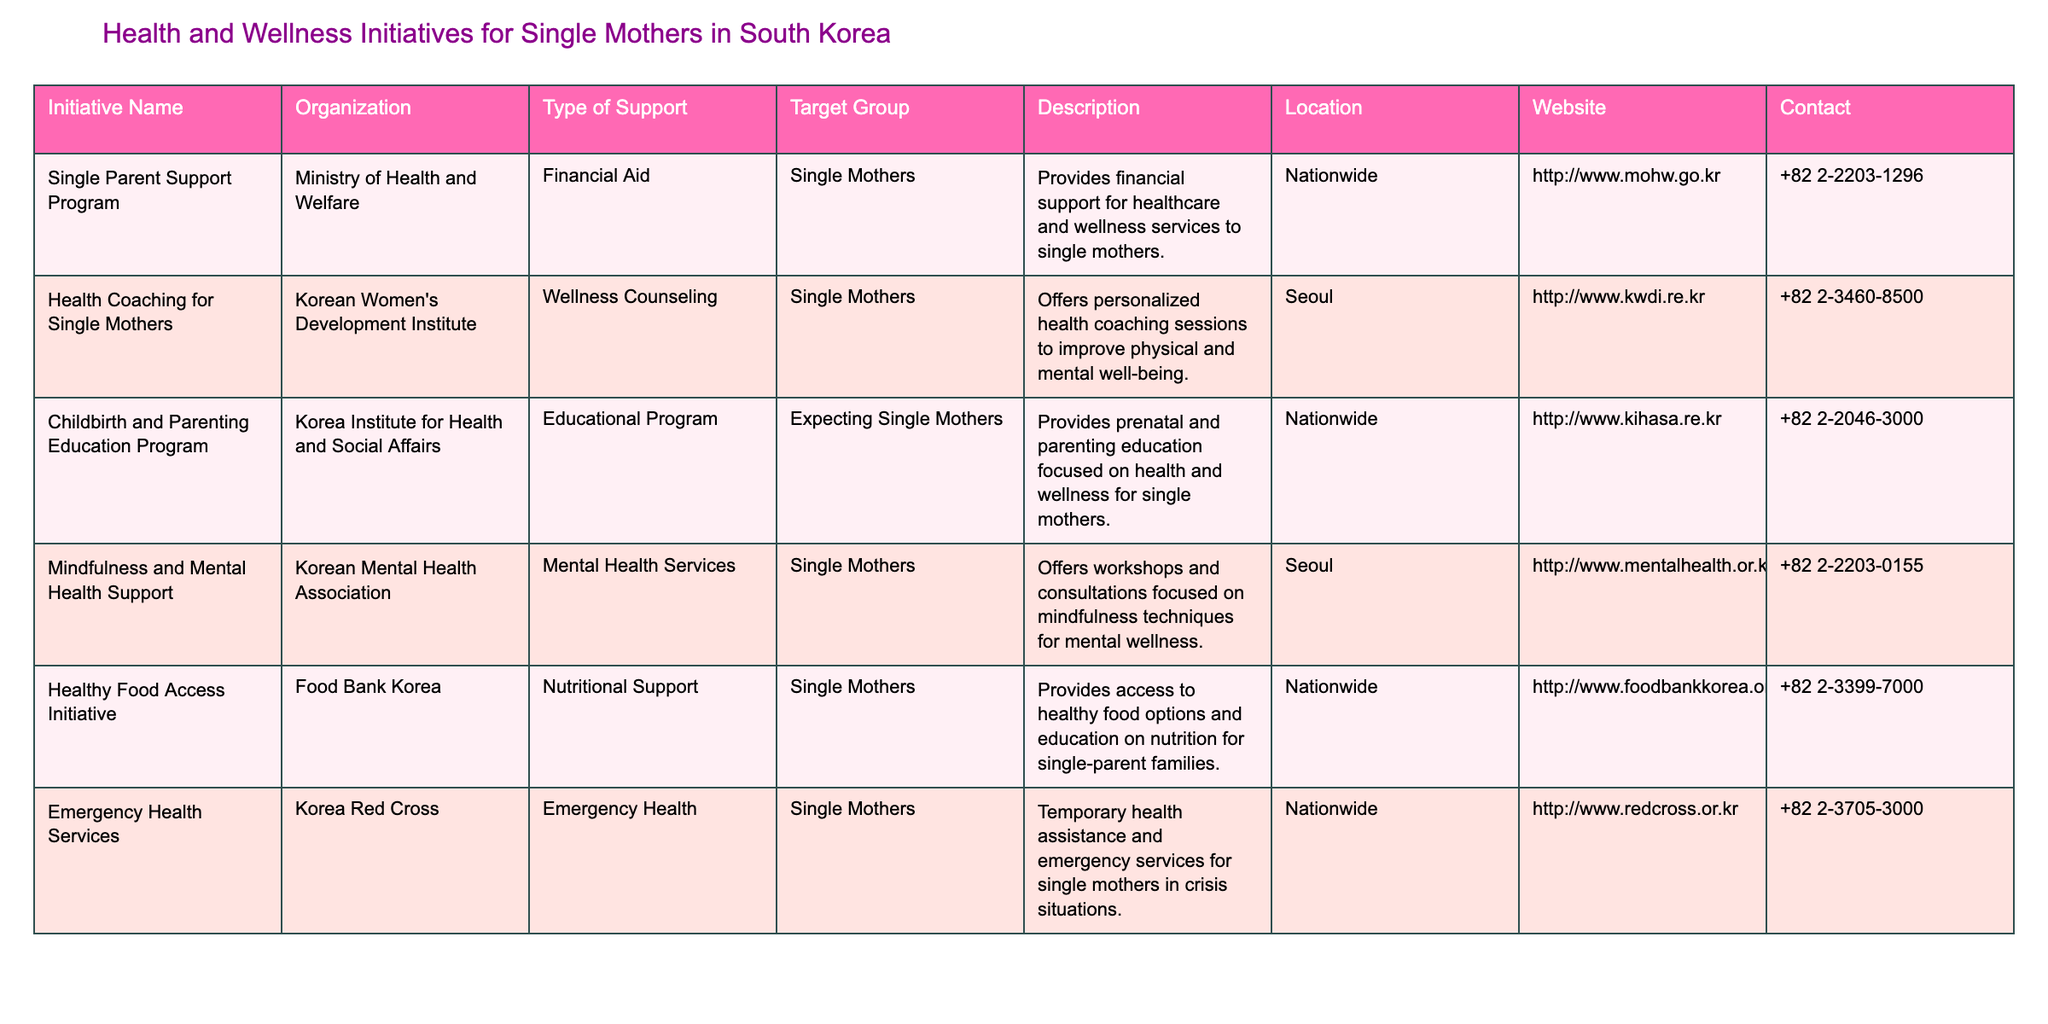What is the initiative that provides financial aid for single mothers? According to the table, the initiative that offers financial aid specifically for single mothers is the "Single Parent Support Program."
Answer: Single Parent Support Program How many initiatives are focused on mental health support for single mothers? The table shows that there are two initiatives related to mental health support: "Mindfulness and Mental Health Support" and "Health Coaching for Single Mothers." Therefore, the total is two.
Answer: 2 Is there a specific initiative for expecting single mothers? The table lists the "Childbirth and Parenting Education Program," which targets expecting single mothers, confirming that there is a specific initiative for this group.
Answer: Yes What type of support does the "Healthy Food Access Initiative" provide? The description of the "Healthy Food Access Initiative" indicates that it provides nutritional support, specifically access to healthy food options and education on nutrition for single-parent families.
Answer: Nutritional Support Which organization offers emergency health services for single mothers? According to the table, the "Korea Red Cross" is the organization that provides emergency health services for single mothers.
Answer: Korea Red Cross What is the location for health coaching sessions available for single mothers? The table specifies that the "Health Coaching for Single Mothers" initiative is located in Seoul.
Answer: Seoul How does the "Emergency Health Services" support single mothers? The table describes that the "Emergency Health Services" initiative provides temporary health assistance and emergency services for single mothers experiencing crisis situations.
Answer: Temporary health assistance Count the total number of initiatives listed in the table. The table lists six different initiatives for single mothers, thus providing a total count of six initiatives.
Answer: 6 Which initiative offers personalized health coaching sessions? The table indicates that "Health Coaching for Single Mothers" provides personalized health coaching sessions aimed at improving physical and mental well-being.
Answer: Health Coaching for Single Mothers Are there any initiatives that are available nationwide? Yes, the table indicates that the "Single Parent Support Program," "Childbirth and Parenting Education Program," "Healthy Food Access Initiative," and "Emergency Health Services" are all available nationwide.
Answer: Yes What type of support does the "Mindfulness and Mental Health Support" offer? According to the table, the "Mindfulness and Mental Health Support" initiative provides mental health services focused on mindfulness techniques for mental wellness.
Answer: Mental health services focused on mindfulness 